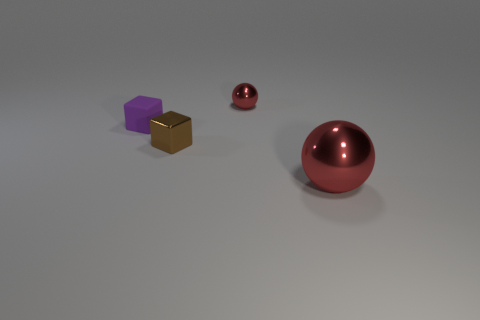Add 2 tiny brown metal blocks. How many objects exist? 6 Add 2 tiny cyan blocks. How many tiny cyan blocks exist? 2 Subtract 0 brown cylinders. How many objects are left? 4 Subtract all small metallic objects. Subtract all purple cubes. How many objects are left? 1 Add 1 brown shiny things. How many brown shiny things are left? 2 